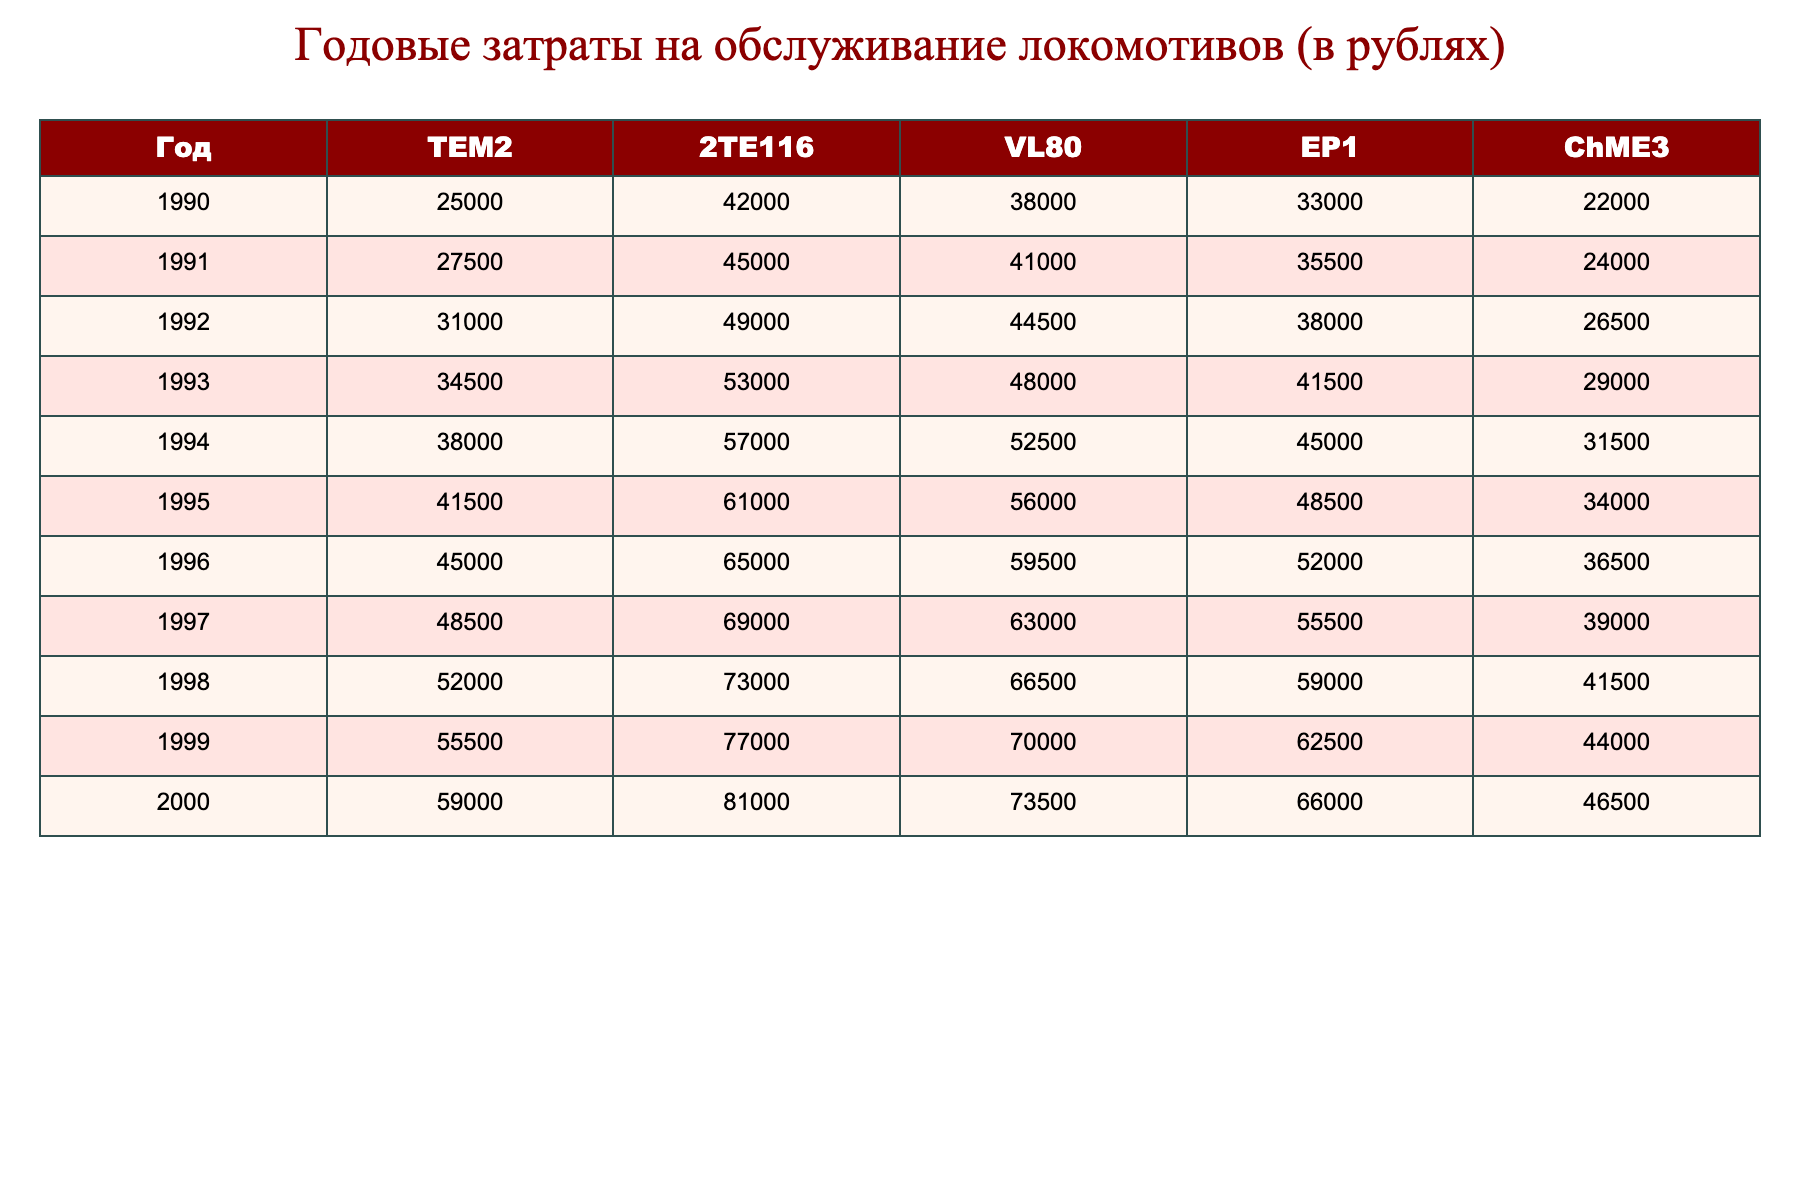What were the annual maintenance costs for the TEM2 locomotive in 1995? By looking at the row for the year 1995 in the TEM2 column, we find the value is 41500.
Answer: 41500 What is the maintenance cost of the VL80 locomotive in 2000? The VL80 column for the year 2000 shows a maintenance cost of 73500.
Answer: 73500 What was the total maintenance cost for EP1 locomotives from 1990 to 1994? We sum the values for EP1 from 1990 to 1994: 33000 + 35500 + 38000 + 41500 + 45000 = 183000.
Answer: 183000 In which year did the ChME3 locomotive have the highest maintenance cost? Looking through the ChME3 column, the highest maintenance cost is 46500 in the year 2000.
Answer: 2000 What was the average annual maintenance cost for the 2TE116 locomotives from 1990 to 2000? Adding the annual costs from 1990 to 2000 gives us 42000 + 45000 + 49000 + 53000 + 57000 + 61000 + 65000 + 69000 + 73000 + 77000 + 81000 = 643000. There are 11 years, so the average is 643000/11 = 58454.55, rounded to 58455.
Answer: 58455 Was the maintenance cost for the EP1 locomotive in 1992 higher than that of the TEM2 locomotive in the same year? The EP1 cost in 1992 is 38000, while the TEM2 cost is 31000. Since 38000 > 31000, the statement is true.
Answer: Yes How much did the maintenance cost for the 2TE116 locomotive increase from 1990 to 2000? The 2TE116 cost in 2000 is 81000, and in 1990 it was 42000. The increase is 81000 - 42000 = 39000.
Answer: 39000 Which locomotive type had the lowest maintenance cost in 1999? Looking at the costs in 1999: TEM2 (55500), 2TE116 (77000), VL80 (70000), EP1 (62500), ChME3 (44000). The lowest is 44000 for ChME3.
Answer: ChME3 What is the difference in maintenance costs between the highest and lowest values recorded in 1995? For 1995, TEM2 is 41500 and ChME3 is 34000. The difference is 41500 - 34000 = 7500.
Answer: 7500 Based on the data, can we say that maintenance costs increased every year for the TEM2 locomotive? The values for TEM2 show a steady increase from 25000 in 1990 to 59000 in 2000. Thus, yes, maintenance costs increased every year.
Answer: Yes 